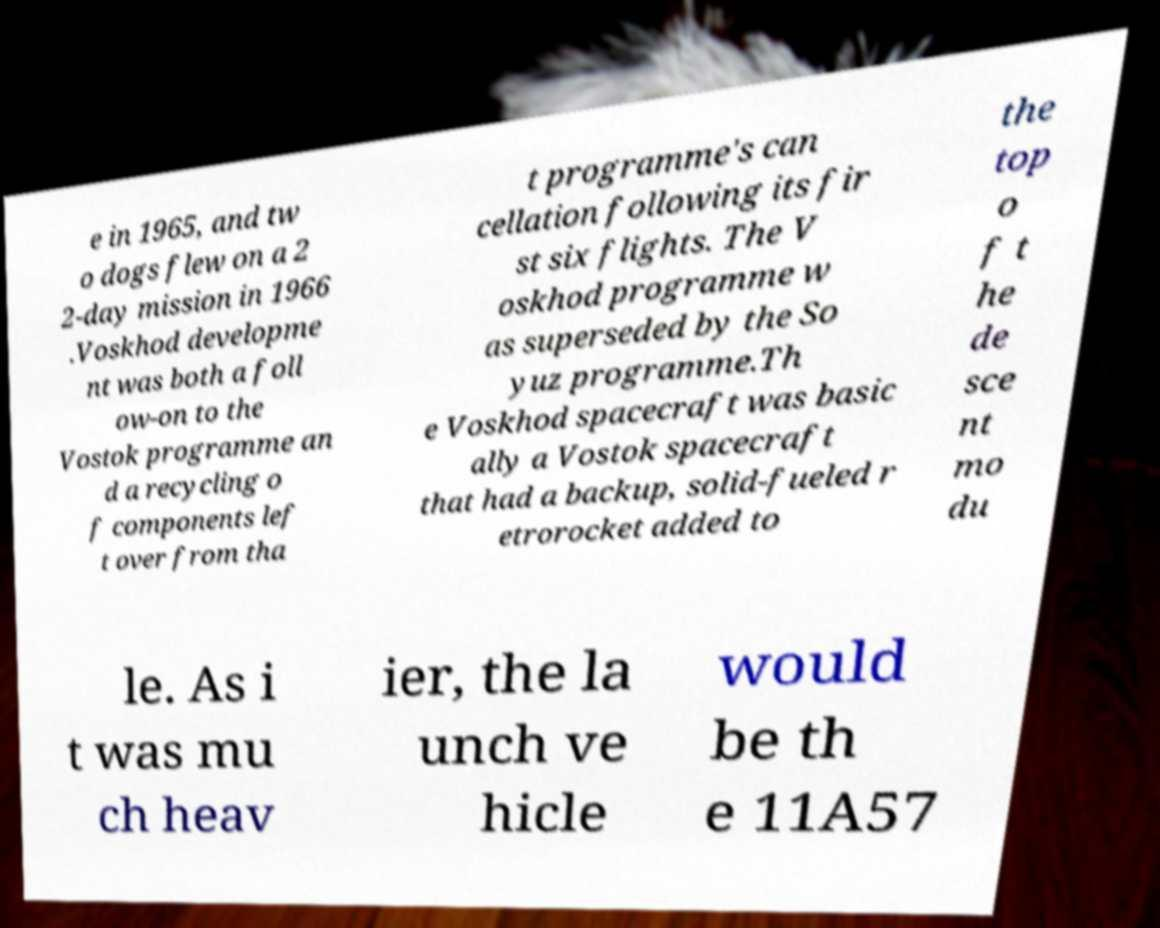There's text embedded in this image that I need extracted. Can you transcribe it verbatim? e in 1965, and tw o dogs flew on a 2 2-day mission in 1966 .Voskhod developme nt was both a foll ow-on to the Vostok programme an d a recycling o f components lef t over from tha t programme's can cellation following its fir st six flights. The V oskhod programme w as superseded by the So yuz programme.Th e Voskhod spacecraft was basic ally a Vostok spacecraft that had a backup, solid-fueled r etrorocket added to the top o f t he de sce nt mo du le. As i t was mu ch heav ier, the la unch ve hicle would be th e 11A57 